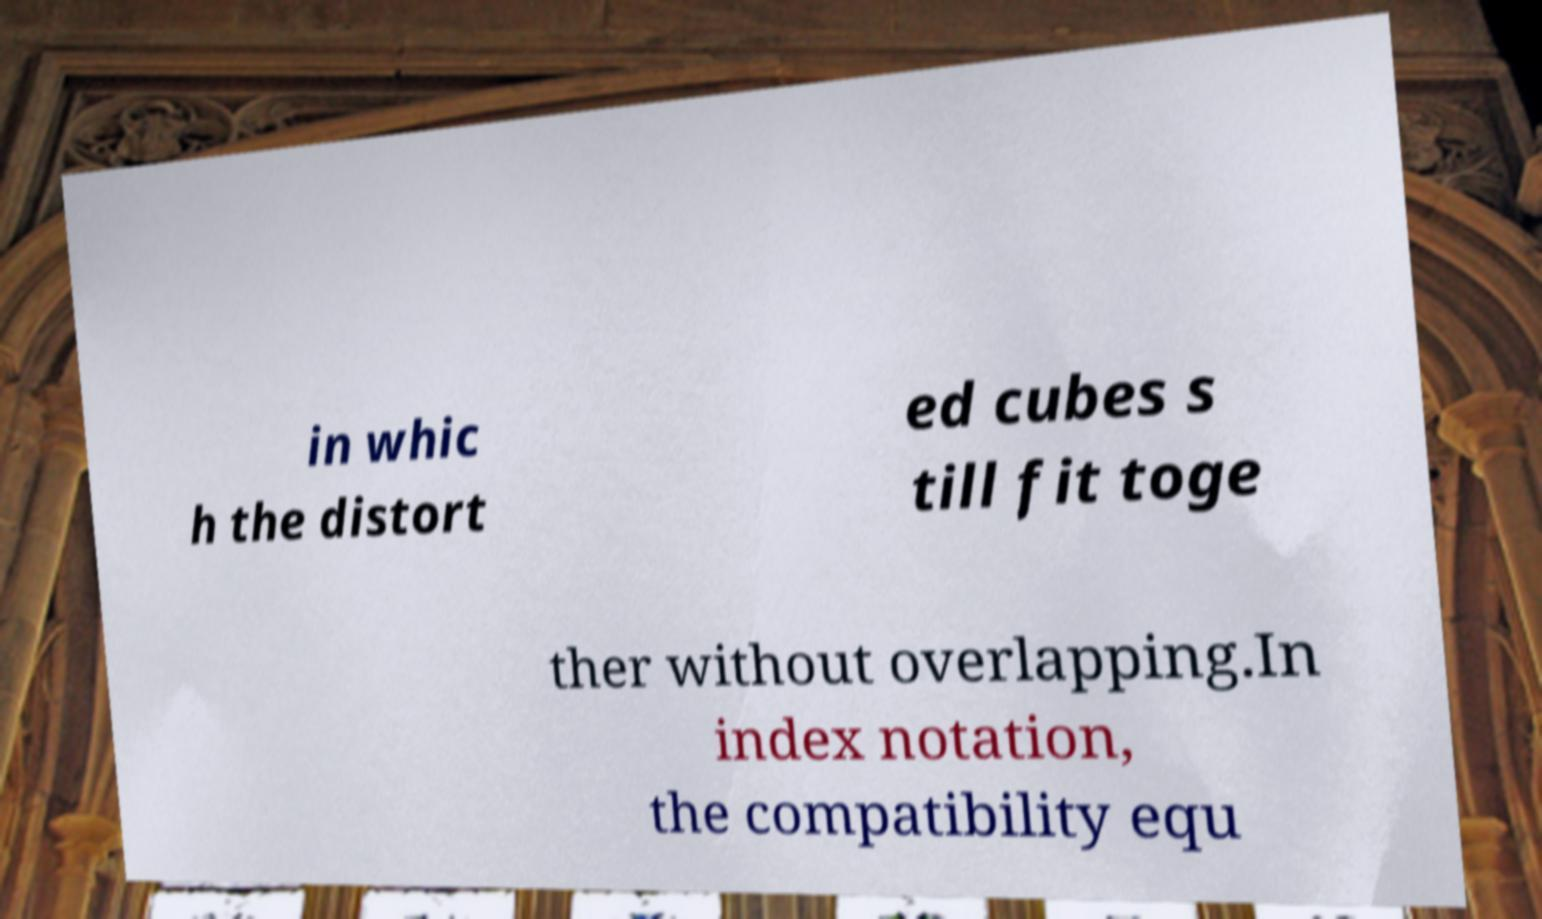What messages or text are displayed in this image? I need them in a readable, typed format. in whic h the distort ed cubes s till fit toge ther without overlapping.In index notation, the compatibility equ 